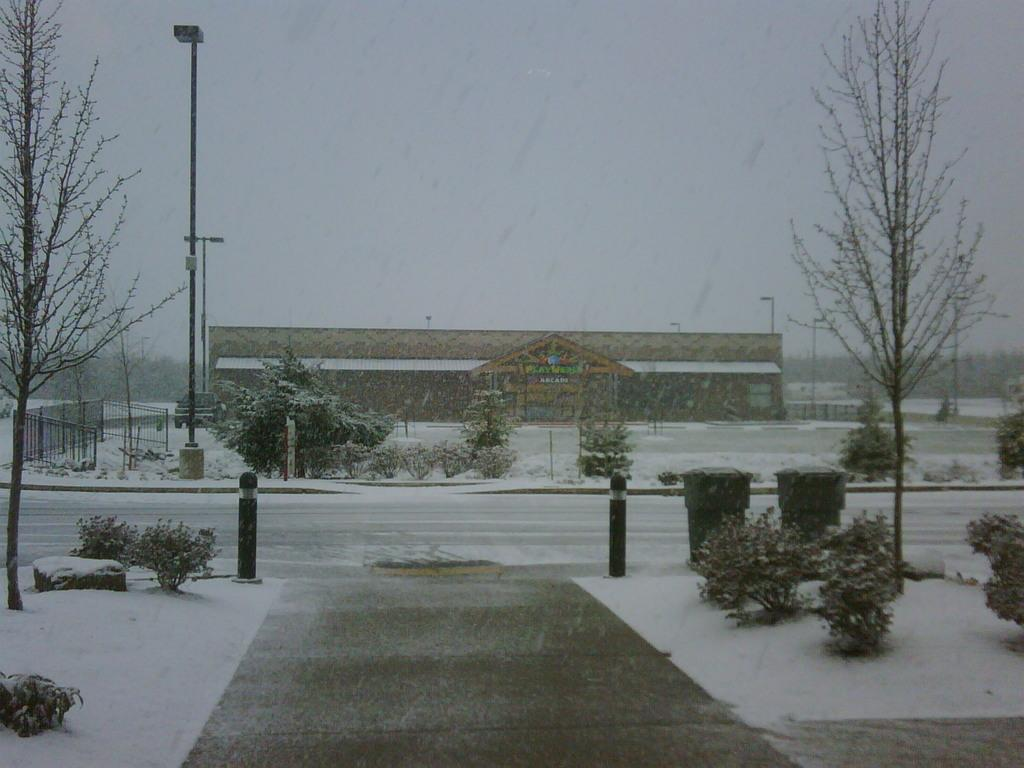What is the condition of the ground in the image? The ground in the image is covered with snow. What can be seen in the background of the image? There is a building and trees visible in the background of the image. What is the tendency of the room to change colors in the image? There is no room present in the image, so it is not possible to determine any tendency for color changes. 